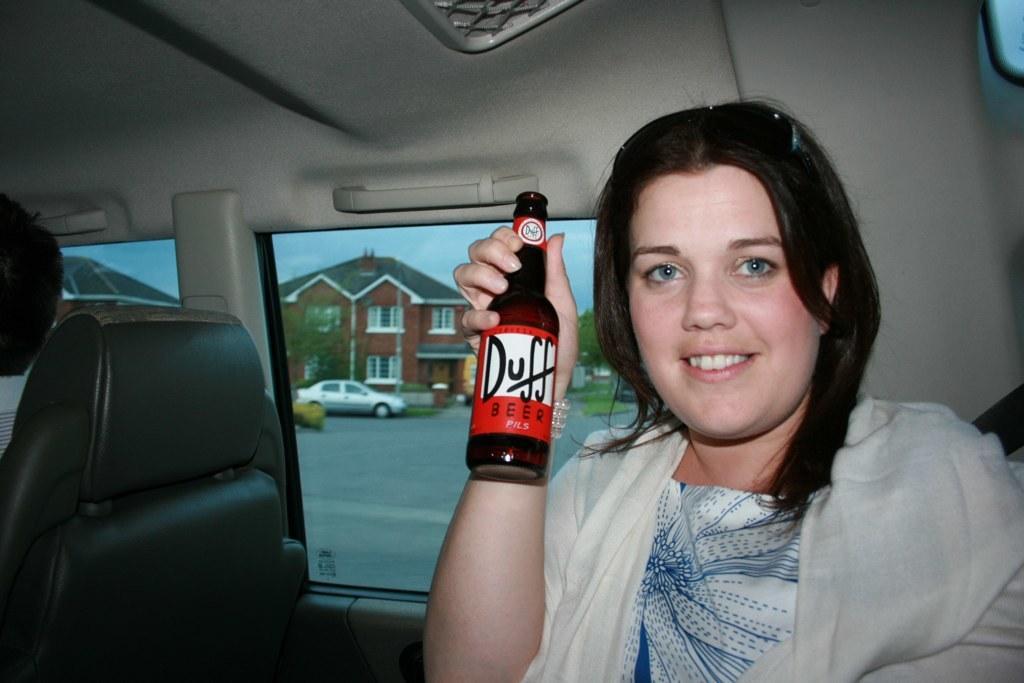Please provide a concise description of this image. In this image I can see a woman holding a bottle. In the background I can see a car and a building. I can see the sky. 